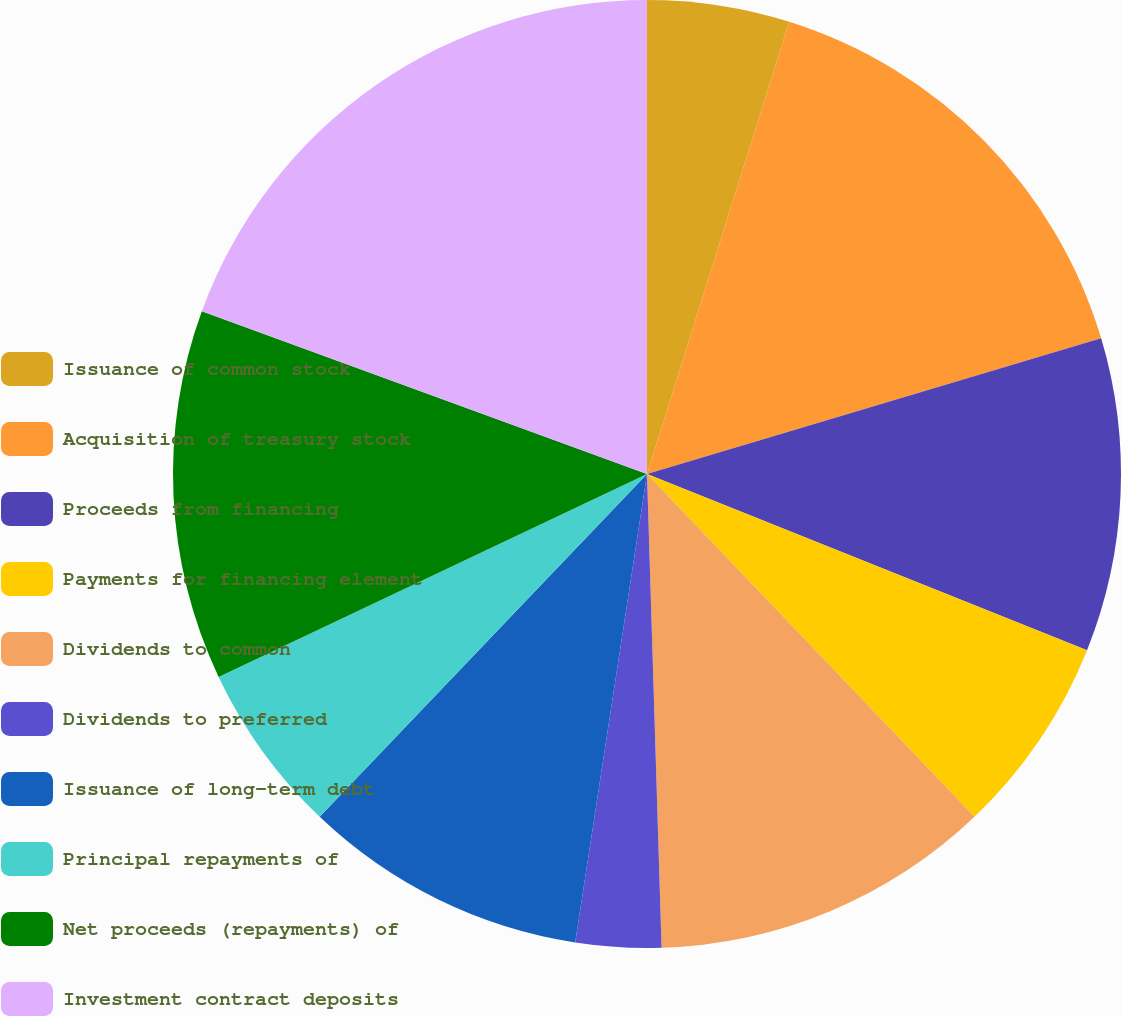Convert chart to OTSL. <chart><loc_0><loc_0><loc_500><loc_500><pie_chart><fcel>Issuance of common stock<fcel>Acquisition of treasury stock<fcel>Proceeds from financing<fcel>Payments for financing element<fcel>Dividends to common<fcel>Dividends to preferred<fcel>Issuance of long-term debt<fcel>Principal repayments of<fcel>Net proceeds (repayments) of<fcel>Investment contract deposits<nl><fcel>4.85%<fcel>15.53%<fcel>10.68%<fcel>6.8%<fcel>11.65%<fcel>2.91%<fcel>9.71%<fcel>5.83%<fcel>12.62%<fcel>19.42%<nl></chart> 